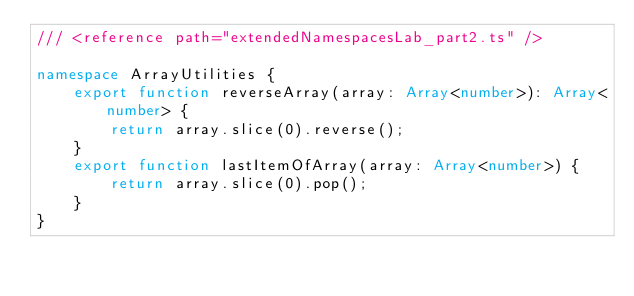<code> <loc_0><loc_0><loc_500><loc_500><_TypeScript_>/// <reference path="extendedNamespacesLab_part2.ts" />

namespace ArrayUtilities {
    export function reverseArray(array: Array<number>): Array<number> {
        return array.slice(0).reverse();
    }
    export function lastItemOfArray(array: Array<number>) {
        return array.slice(0).pop();
    }
}</code> 